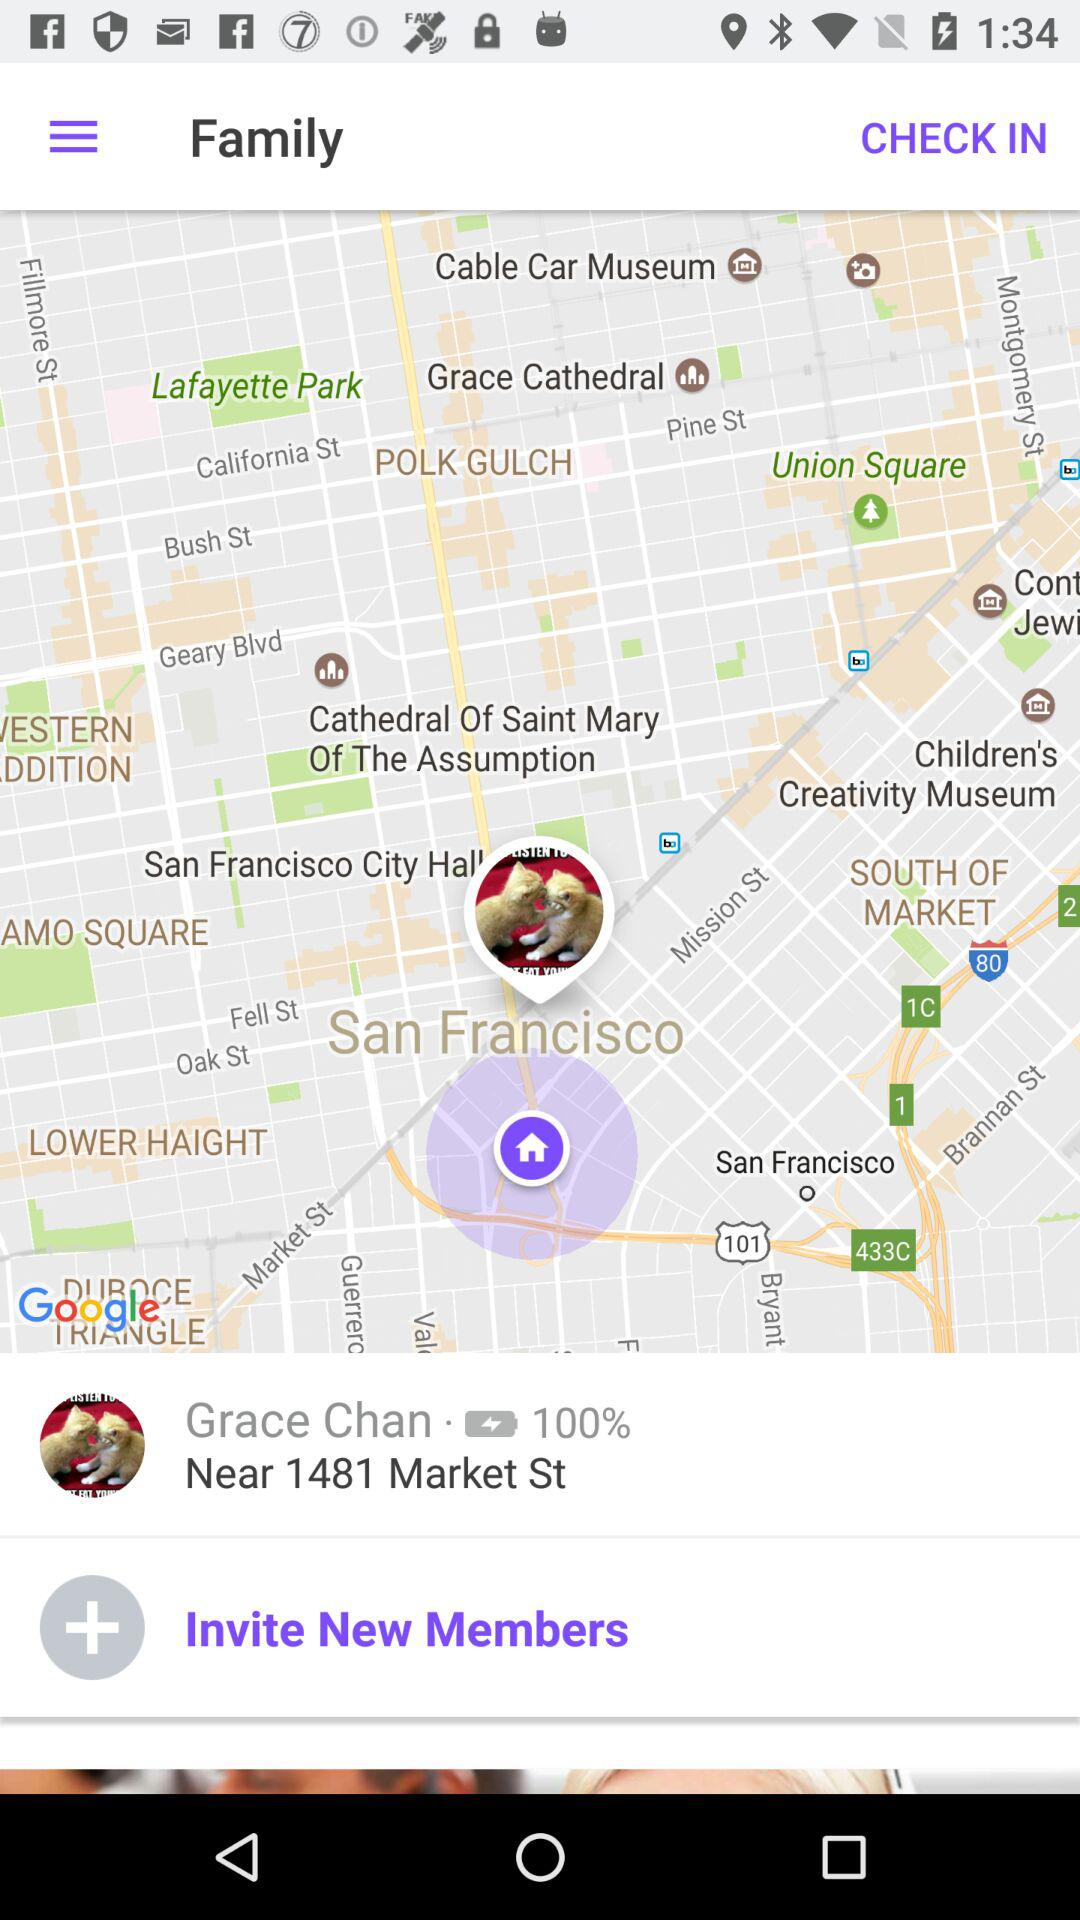How much is the battery charged? The battery is 100% charged. 